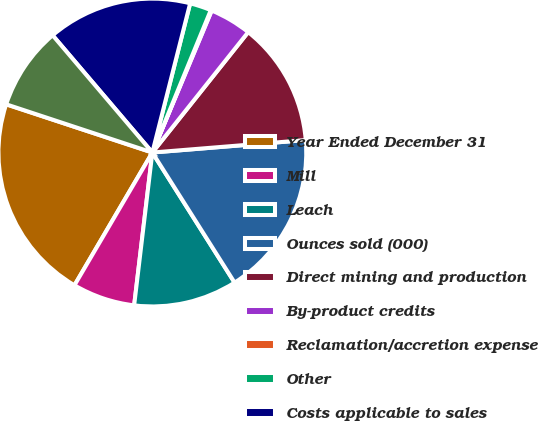Convert chart. <chart><loc_0><loc_0><loc_500><loc_500><pie_chart><fcel>Year Ended December 31<fcel>Mill<fcel>Leach<fcel>Ounces sold (000)<fcel>Direct mining and production<fcel>By-product credits<fcel>Reclamation/accretion expense<fcel>Other<fcel>Costs applicable to sales<fcel>Depreciation depletion and<nl><fcel>21.63%<fcel>6.56%<fcel>10.86%<fcel>17.32%<fcel>13.01%<fcel>4.4%<fcel>0.1%<fcel>2.25%<fcel>15.17%<fcel>8.71%<nl></chart> 